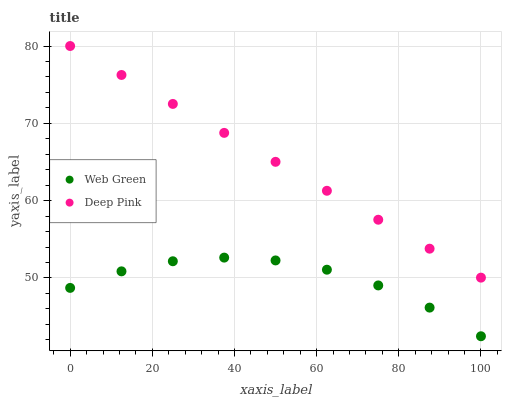Does Web Green have the minimum area under the curve?
Answer yes or no. Yes. Does Deep Pink have the maximum area under the curve?
Answer yes or no. Yes. Does Web Green have the maximum area under the curve?
Answer yes or no. No. Is Deep Pink the smoothest?
Answer yes or no. Yes. Is Web Green the roughest?
Answer yes or no. Yes. Is Web Green the smoothest?
Answer yes or no. No. Does Web Green have the lowest value?
Answer yes or no. Yes. Does Deep Pink have the highest value?
Answer yes or no. Yes. Does Web Green have the highest value?
Answer yes or no. No. Is Web Green less than Deep Pink?
Answer yes or no. Yes. Is Deep Pink greater than Web Green?
Answer yes or no. Yes. Does Web Green intersect Deep Pink?
Answer yes or no. No. 